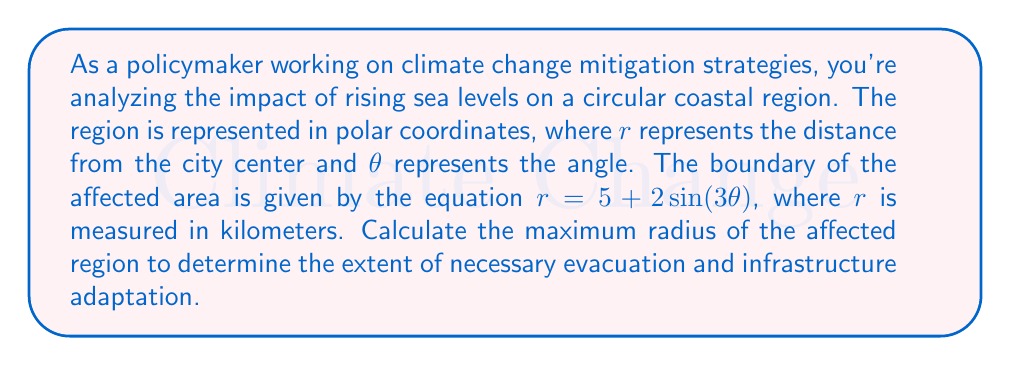Show me your answer to this math problem. To find the maximum radius of the affected region, we need to determine the maximum value of $r$ in the given polar equation:

$r = 5 + 2\sin(3\theta)$

1) The maximum value of $r$ will occur when $\sin(3\theta)$ is at its maximum, which is 1.

2) Therefore, the maximum radius is:

   $r_{max} = 5 + 2(1) = 5 + 2 = 7$

3) We can verify this by considering the properties of the sine function:
   - The sine function oscillates between -1 and 1
   - When $\sin(3\theta) = 1$, $r$ will be at its maximum
   - When $\sin(3\theta) = -1$, $r$ will be at its minimum

4) The minimum radius would be:
   $r_{min} = 5 + 2(-1) = 5 - 2 = 3$

5) This means the radius of the affected area varies between 3 km and 7 km from the city center, with 7 km being the maximum extent.

[asy]
import graph;
size(200);
real r(real t) {return 5+2*sin(3t);}
draw(polargraph(r,0,2pi),blue);
draw(circle((0,0),7),red+dashed);
draw(circle((0,0),5),green+dashed);
label("Max radius (7 km)",(-5,5),red);
label("Average (5 km)",(3,-4),green);
dot((0,0));
label("City center",(0,-0.5),S);
[/asy]

The diagram above illustrates the shape of the affected region (blue), the maximum radius (red dashed circle), and the average radius (green dashed circle).
Answer: The maximum radius of the circular region affected by rising sea levels is 7 kilometers. 